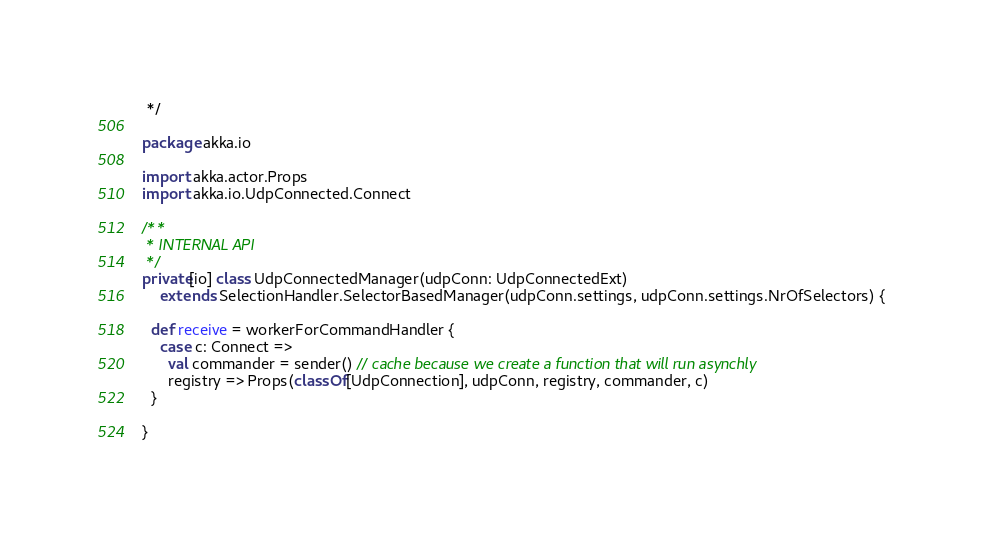Convert code to text. <code><loc_0><loc_0><loc_500><loc_500><_Scala_> */

package akka.io

import akka.actor.Props
import akka.io.UdpConnected.Connect

/**
 * INTERNAL API
 */
private[io] class UdpConnectedManager(udpConn: UdpConnectedExt)
    extends SelectionHandler.SelectorBasedManager(udpConn.settings, udpConn.settings.NrOfSelectors) {

  def receive = workerForCommandHandler {
    case c: Connect =>
      val commander = sender() // cache because we create a function that will run asynchly
      registry => Props(classOf[UdpConnection], udpConn, registry, commander, c)
  }

}
</code> 